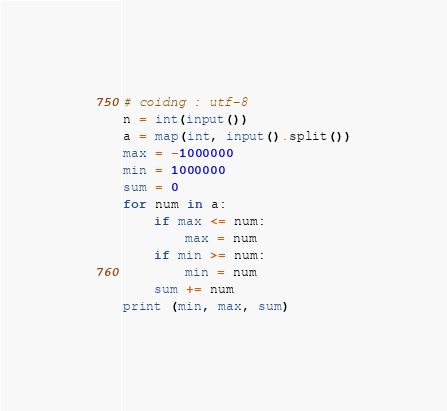Convert code to text. <code><loc_0><loc_0><loc_500><loc_500><_Python_># coidng : utf-8
n = int(input())
a = map(int, input().split())
max = -1000000
min = 1000000
sum = 0
for num in a:
    if max <= num:
        max = num
    if min >= num:
        min = num
    sum += num
print (min, max, sum)
</code> 